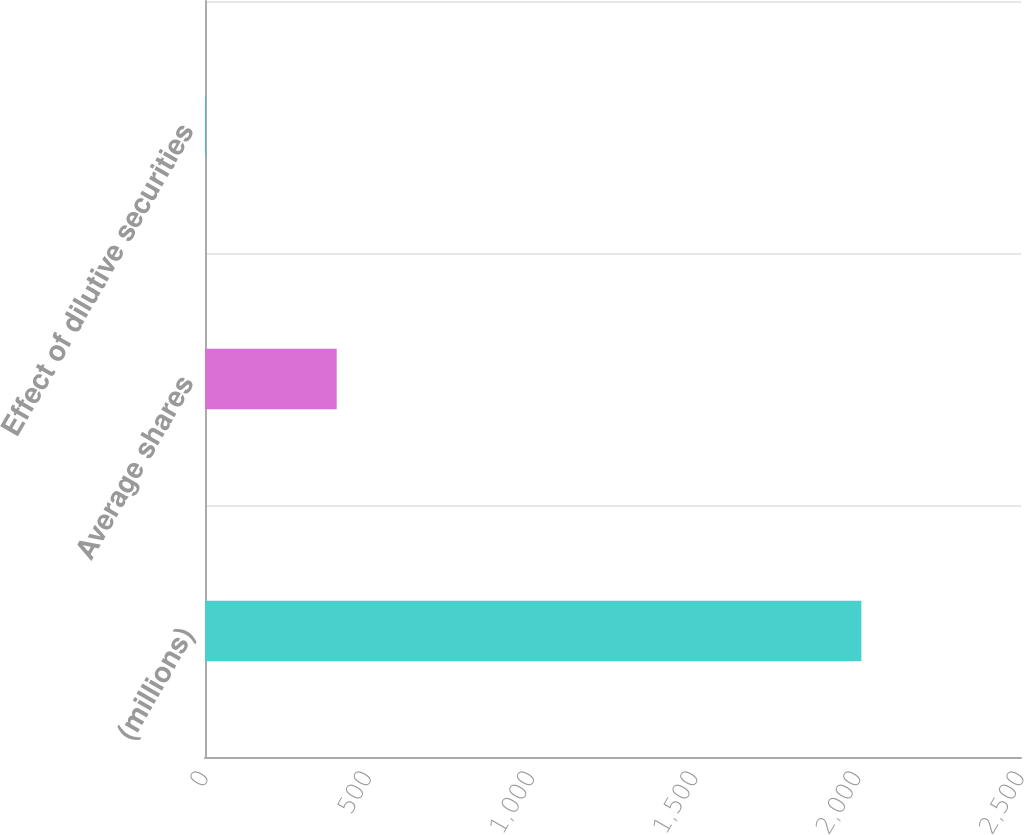Convert chart. <chart><loc_0><loc_0><loc_500><loc_500><bar_chart><fcel>(millions)<fcel>Average shares<fcel>Effect of dilutive securities<nl><fcel>2011<fcel>403.48<fcel>1.6<nl></chart> 